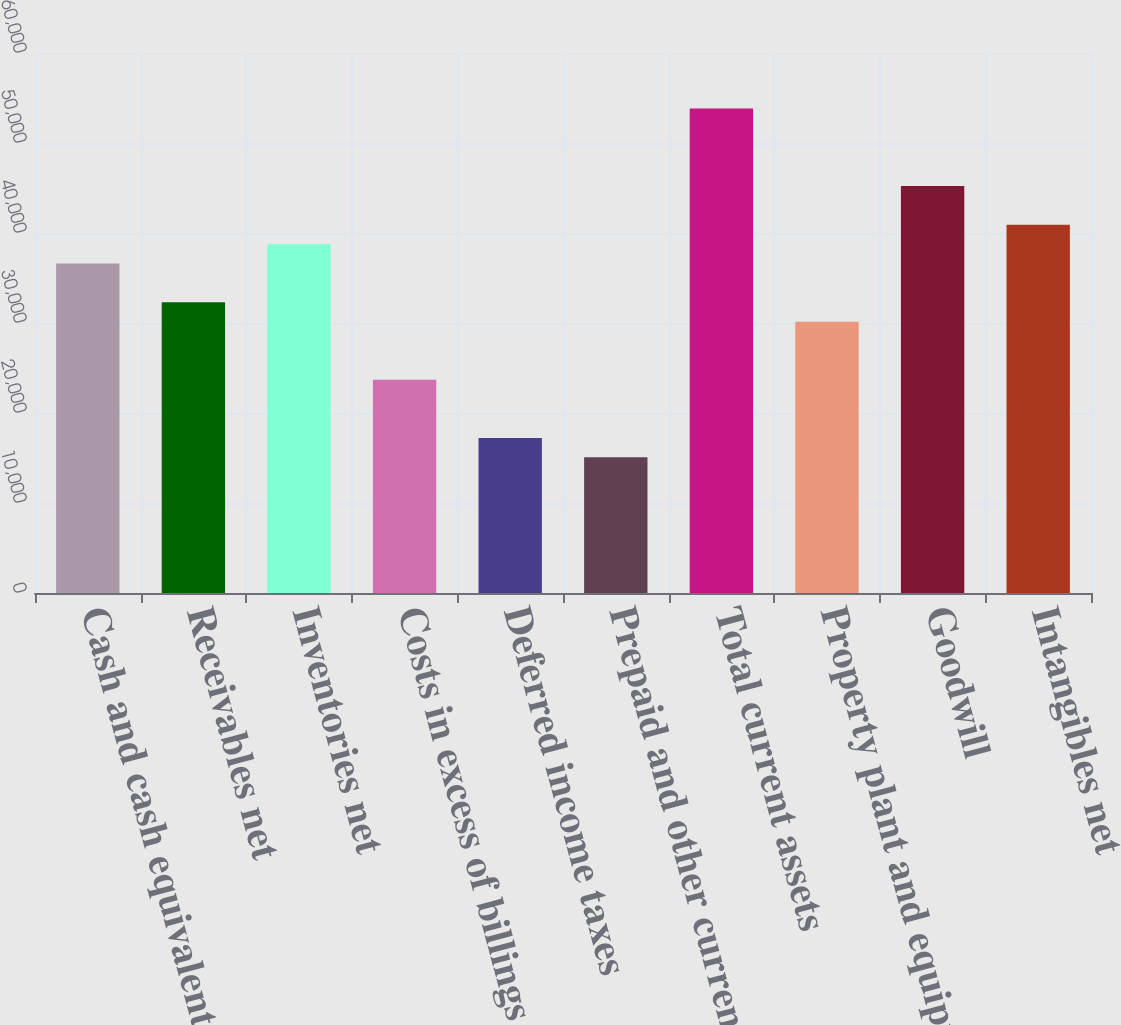<chart> <loc_0><loc_0><loc_500><loc_500><bar_chart><fcel>Cash and cash equivalents<fcel>Receivables net<fcel>Inventories net<fcel>Costs in excess of billings<fcel>Deferred income taxes<fcel>Prepaid and other current<fcel>Total current assets<fcel>Property plant and equipment<fcel>Goodwill<fcel>Intangibles net<nl><fcel>36601.6<fcel>32296<fcel>38754.4<fcel>23684.8<fcel>17226.4<fcel>15073.6<fcel>53824<fcel>30143.2<fcel>45212.8<fcel>40907.2<nl></chart> 